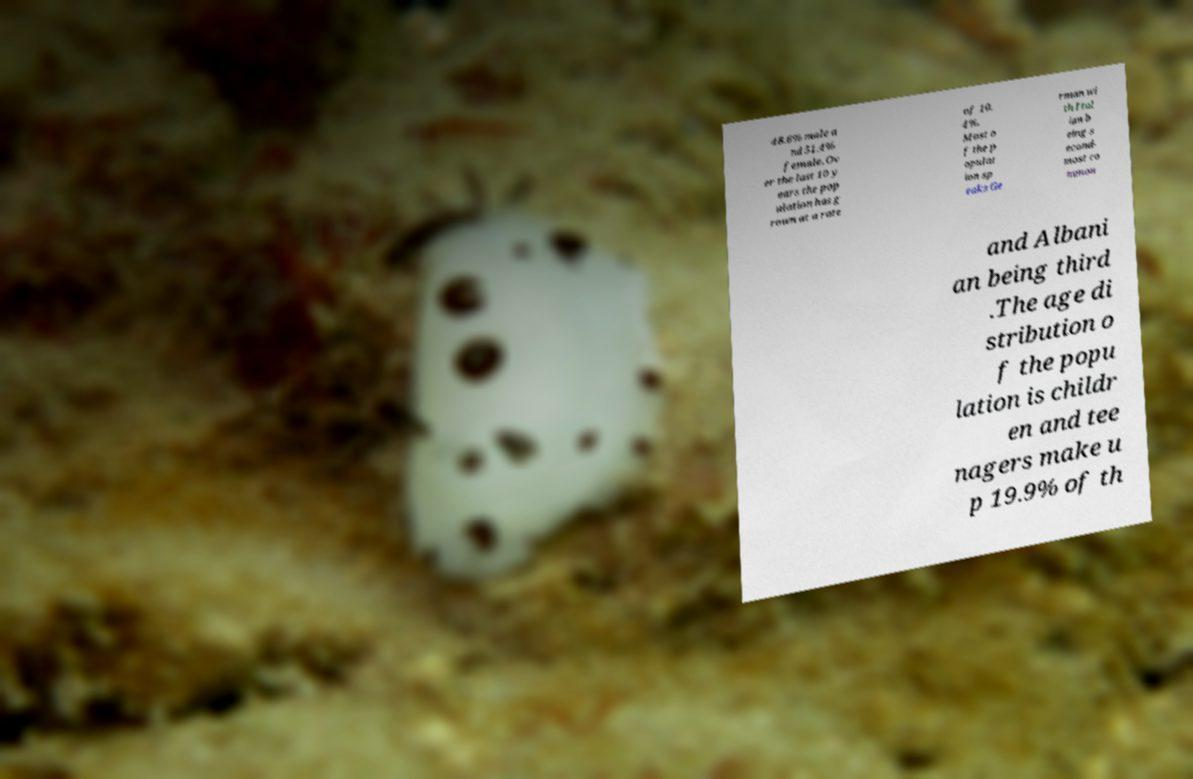I need the written content from this picture converted into text. Can you do that? 48.6% male a nd 51.4% female. Ov er the last 10 y ears the pop ulation has g rown at a rate of 10. 4%. Most o f the p opulat ion sp eaks Ge rman wi th Ital ian b eing s econd- most co mmon and Albani an being third .The age di stribution o f the popu lation is childr en and tee nagers make u p 19.9% of th 